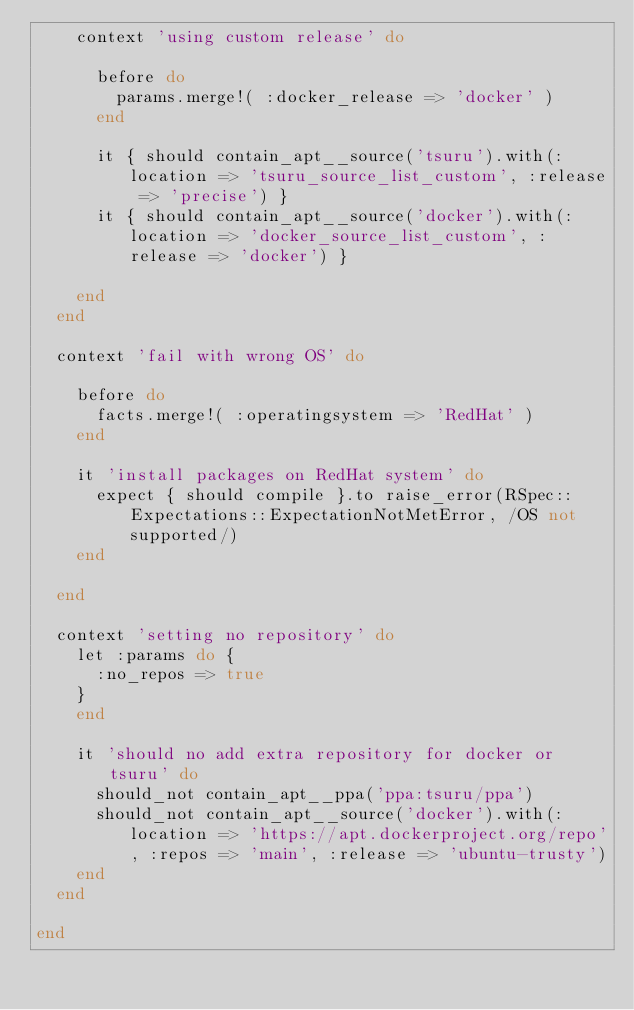Convert code to text. <code><loc_0><loc_0><loc_500><loc_500><_Ruby_>    context 'using custom release' do

      before do
        params.merge!( :docker_release => 'docker' )
      end

      it { should contain_apt__source('tsuru').with(:location => 'tsuru_source_list_custom', :release => 'precise') }
      it { should contain_apt__source('docker').with(:location => 'docker_source_list_custom', :release => 'docker') }

    end
  end

  context 'fail with wrong OS' do

    before do
      facts.merge!( :operatingsystem => 'RedHat' )
    end

    it 'install packages on RedHat system' do
      expect { should compile }.to raise_error(RSpec::Expectations::ExpectationNotMetError, /OS not supported/)
    end

  end

  context 'setting no repository' do
    let :params do {
      :no_repos => true
    }
    end

    it 'should no add extra repository for docker or tsuru' do
      should_not contain_apt__ppa('ppa:tsuru/ppa')
      should_not contain_apt__source('docker').with(:location => 'https://apt.dockerproject.org/repo', :repos => 'main', :release => 'ubuntu-trusty')
    end
  end

end
</code> 